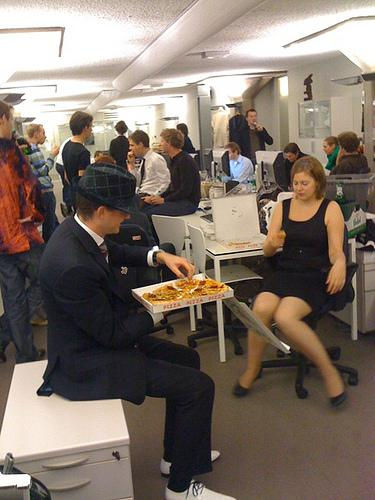Question: what kind of lights are these?
Choices:
A. Broken.
B. Purple.
C. Round.
D. Fluorescent.
Answer with the letter. Answer: D Question: where is the plaid hat?
Choices:
A. On the shelf.
B. On the bed.
C. On the man's head.
D. On the table.
Answer with the letter. Answer: C Question: what is written on the box?
Choices:
A. Sneakers.
B. Apple.
C. Pizza pizza pizza.
D. 19' Television.
Answer with the letter. Answer: C Question: what kind of chairs are these?
Choices:
A. Wooden rocking.
B. Swivel chairs.
C. Metal.
D. Plastic.
Answer with the letter. Answer: B 